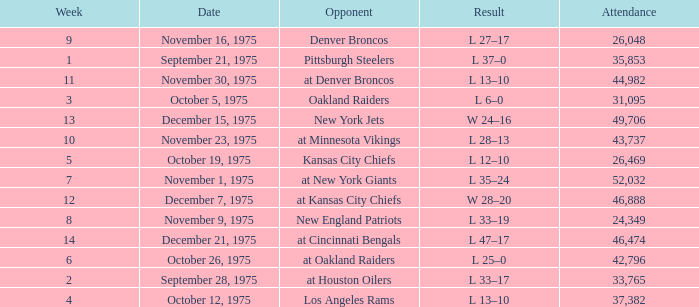What is the average Week when the result was w 28–20, and there were more than 46,888 in attendance? None. 